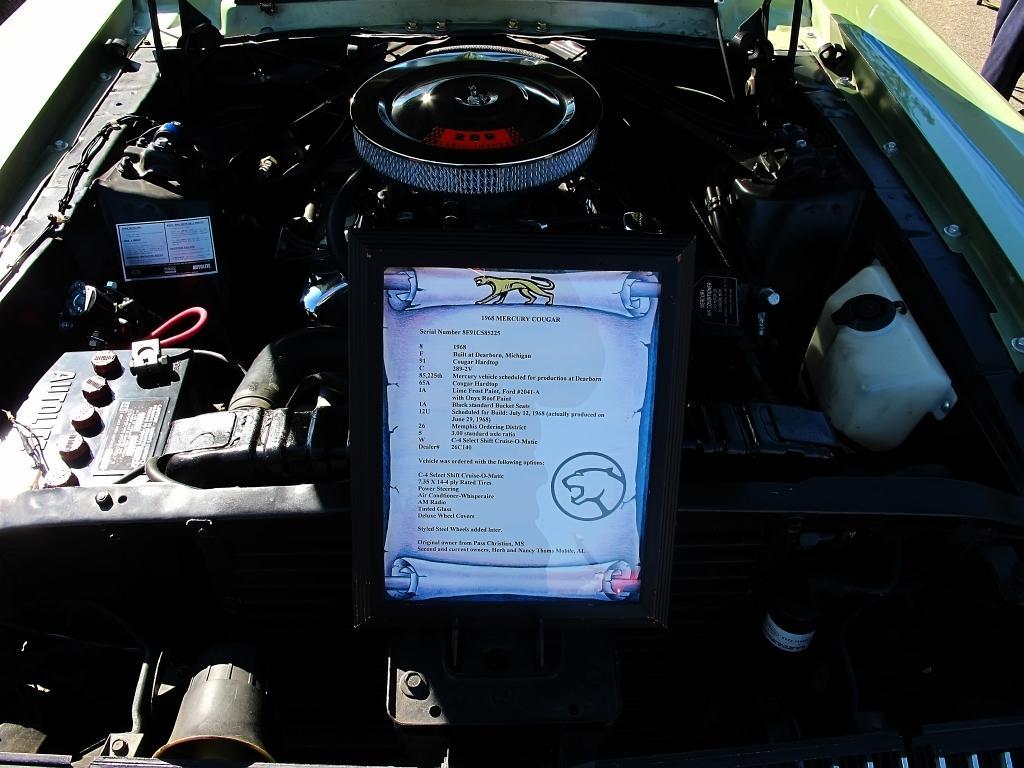Can you describe this image briefly? There is a engine of a car. On that there is a notice with something written on it. On the left side there is a battery. On the right side there is a tank. In the back we can see car bonnet. Also the sides of the car is visible. 